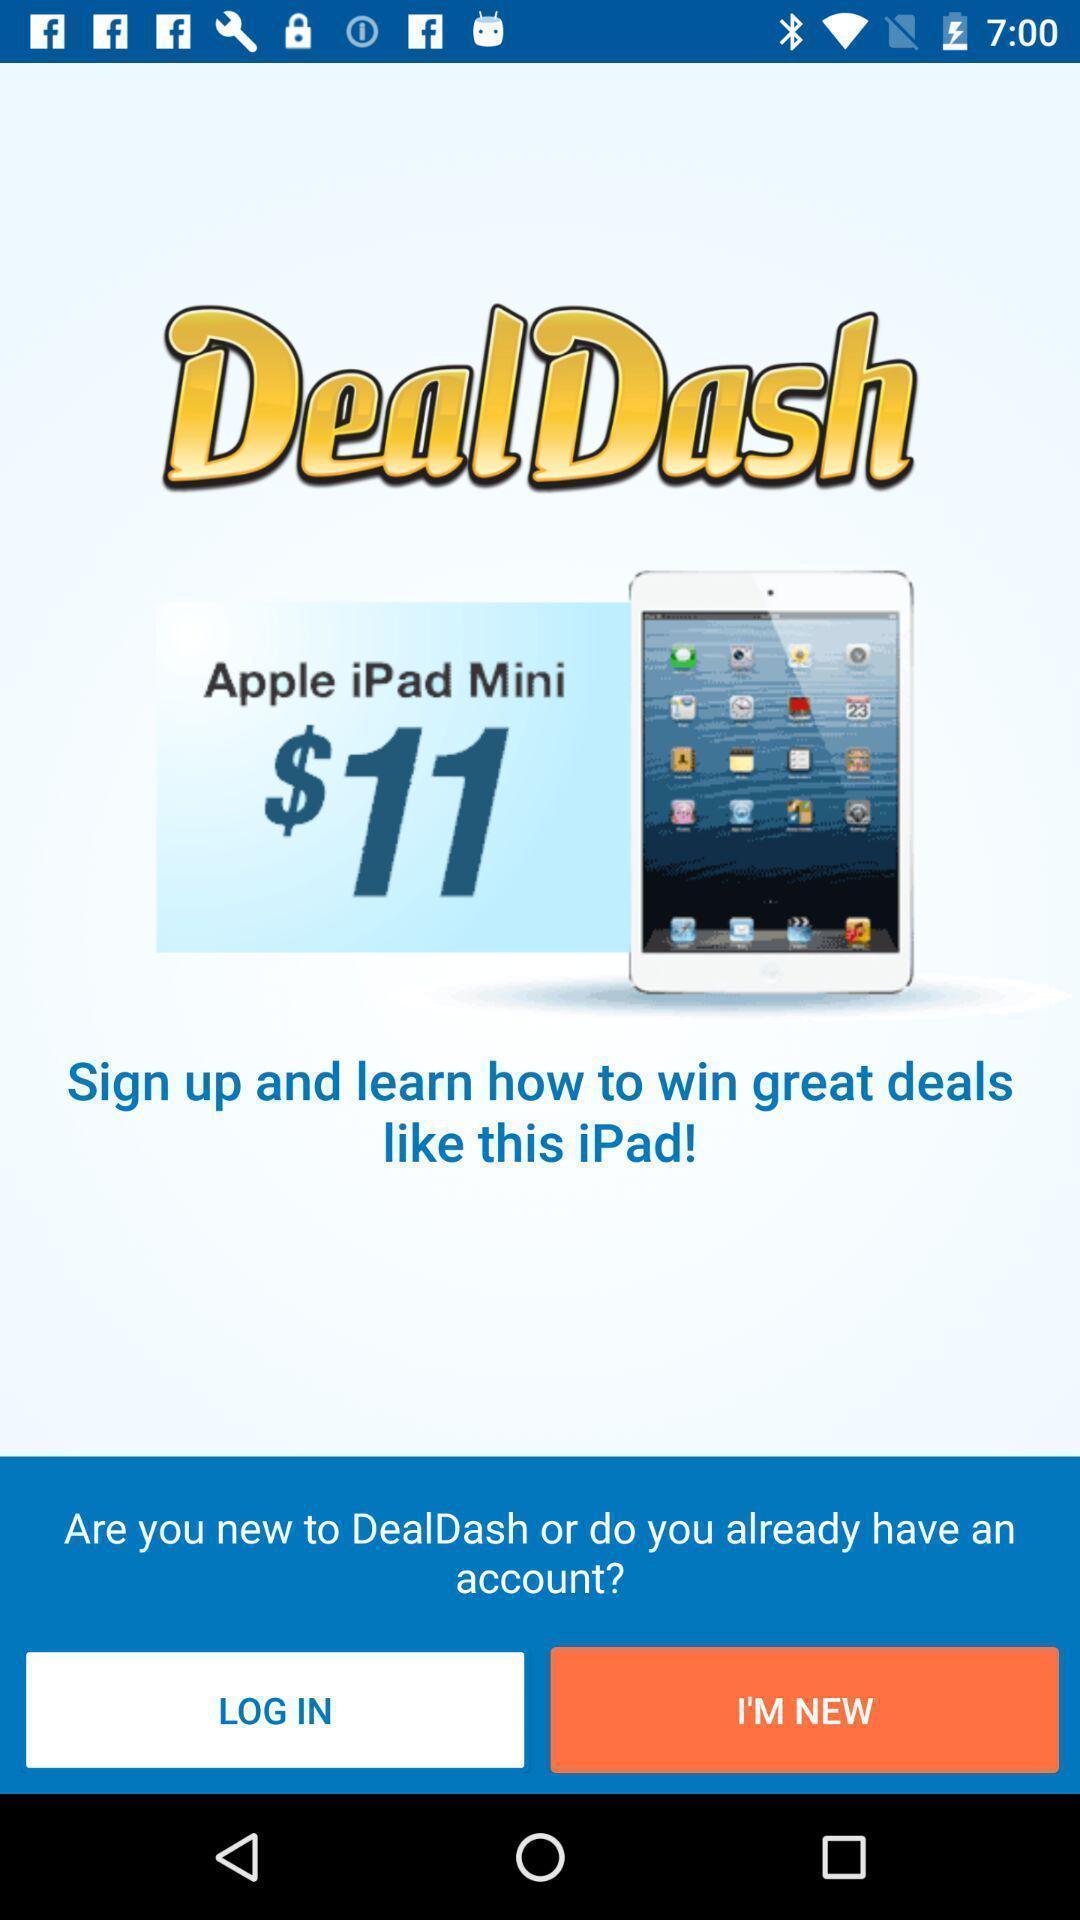Tell me what you see in this picture. Login page. 